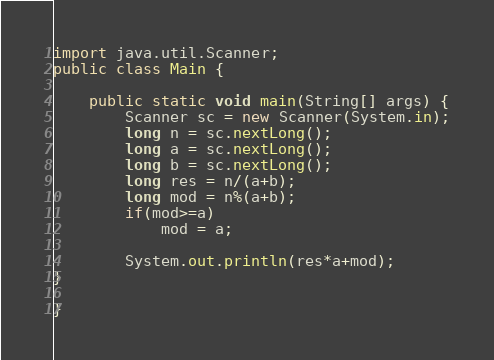<code> <loc_0><loc_0><loc_500><loc_500><_Java_>import java.util.Scanner;
public class Main {

	public static void main(String[] args) {
		Scanner sc = new Scanner(System.in);
		long n = sc.nextLong();
		long a = sc.nextLong();
		long b = sc.nextLong();
		long res = n/(a+b);
		long mod = n%(a+b);
		if(mod>=a)
			mod = a;
		
		System.out.println(res*a+mod);
}

}
</code> 